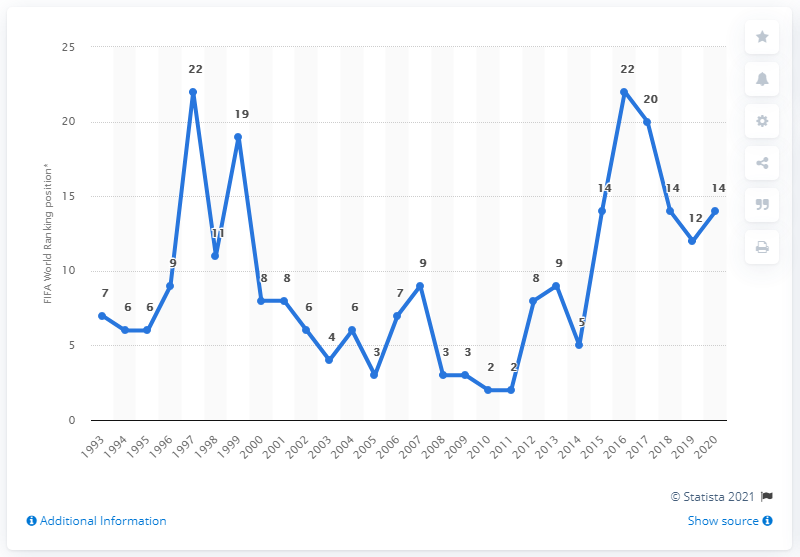Point out several critical features in this image. The Dutch women won a European title in the year 2017. 